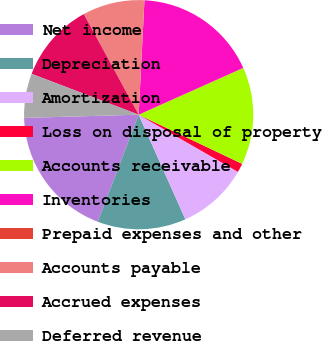Convert chart to OTSL. <chart><loc_0><loc_0><loc_500><loc_500><pie_chart><fcel>Net income<fcel>Depreciation<fcel>Amortization<fcel>Loss on disposal of property<fcel>Accounts receivable<fcel>Inventories<fcel>Prepaid expenses and other<fcel>Accounts payable<fcel>Accrued expenses<fcel>Deferred revenue<nl><fcel>18.74%<fcel>12.5%<fcel>10.0%<fcel>1.26%<fcel>13.75%<fcel>17.5%<fcel>0.01%<fcel>8.75%<fcel>11.25%<fcel>6.25%<nl></chart> 